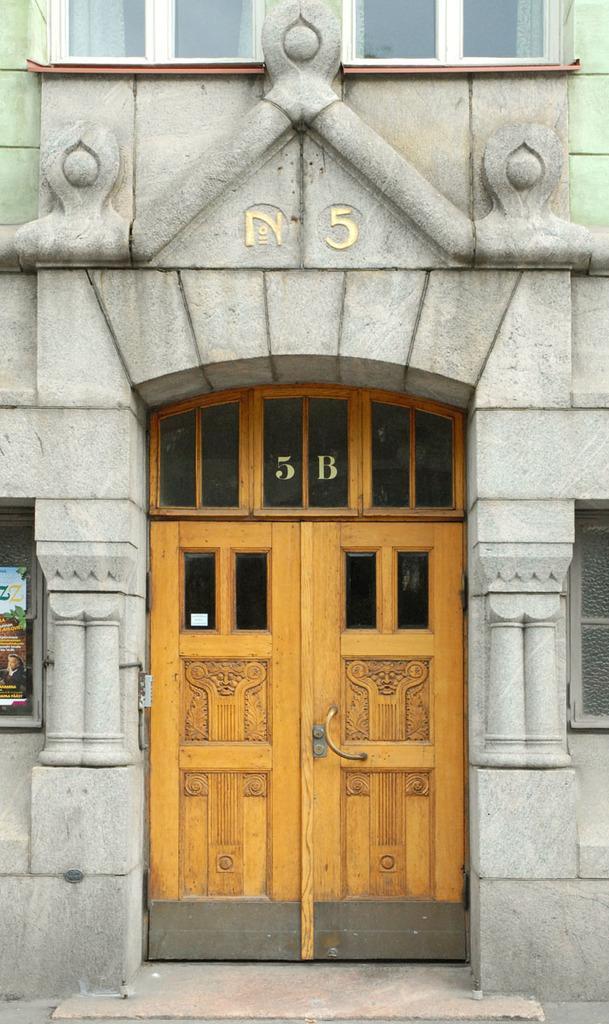In one or two sentences, can you explain what this image depicts? In this image we can see a door of an building. On the right and left sides we can see windows. 